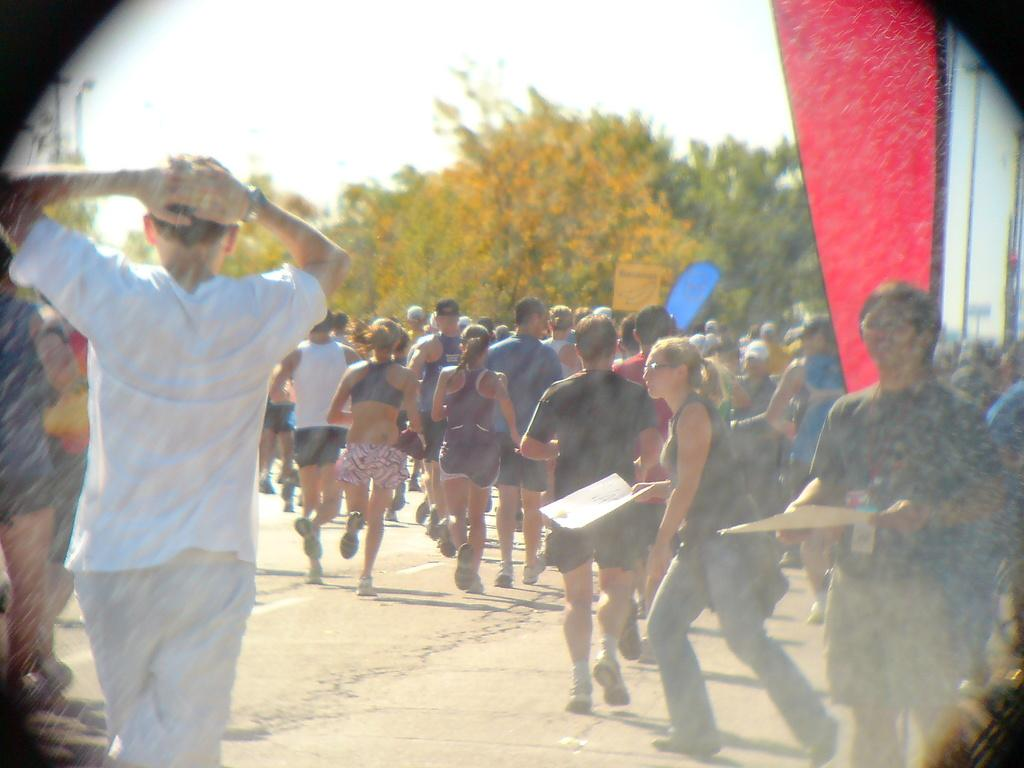What are the people in the image doing? Some people are running, and some are walking in the image. What can be seen in the background of the image? There are trees and the sky visible in the background of the image. What type of camera is being used by the people in the image? There is no camera visible in the image, and it is not mentioned that the people are using one. What rules are being followed by the people in the image? There is no information about any rules being followed by the people in the image. 